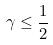<formula> <loc_0><loc_0><loc_500><loc_500>\gamma \leq \frac { 1 } { 2 }</formula> 